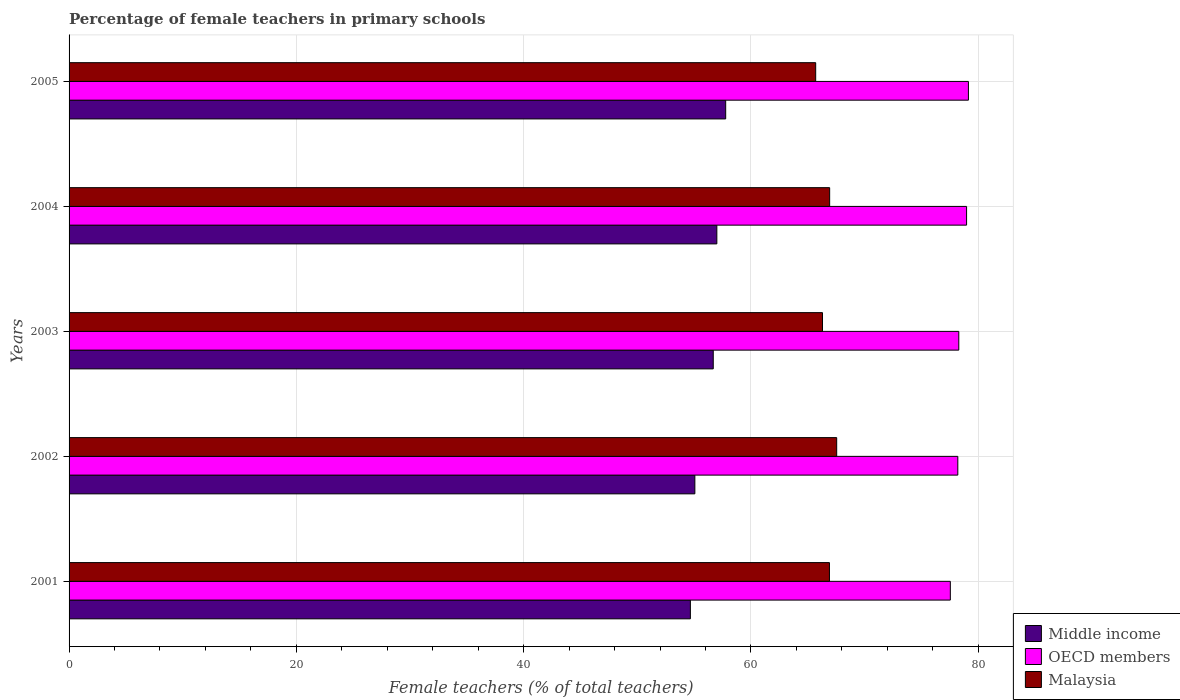How many different coloured bars are there?
Provide a succinct answer. 3. How many groups of bars are there?
Your answer should be compact. 5. Are the number of bars per tick equal to the number of legend labels?
Your answer should be very brief. Yes. Are the number of bars on each tick of the Y-axis equal?
Your answer should be compact. Yes. How many bars are there on the 1st tick from the bottom?
Offer a terse response. 3. What is the label of the 1st group of bars from the top?
Provide a short and direct response. 2005. In how many cases, is the number of bars for a given year not equal to the number of legend labels?
Offer a very short reply. 0. What is the percentage of female teachers in Middle income in 2003?
Provide a succinct answer. 56.68. Across all years, what is the maximum percentage of female teachers in Malaysia?
Ensure brevity in your answer.  67.54. Across all years, what is the minimum percentage of female teachers in OECD members?
Give a very brief answer. 77.54. In which year was the percentage of female teachers in Middle income maximum?
Offer a very short reply. 2005. In which year was the percentage of female teachers in Malaysia minimum?
Ensure brevity in your answer.  2005. What is the total percentage of female teachers in OECD members in the graph?
Offer a terse response. 392.13. What is the difference between the percentage of female teachers in Middle income in 2002 and that in 2003?
Your response must be concise. -1.62. What is the difference between the percentage of female teachers in OECD members in 2001 and the percentage of female teachers in Malaysia in 2003?
Offer a very short reply. 11.25. What is the average percentage of female teachers in Malaysia per year?
Make the answer very short. 66.67. In the year 2002, what is the difference between the percentage of female teachers in Middle income and percentage of female teachers in OECD members?
Your answer should be compact. -23.14. In how many years, is the percentage of female teachers in Middle income greater than 40 %?
Provide a short and direct response. 5. What is the ratio of the percentage of female teachers in OECD members in 2001 to that in 2005?
Make the answer very short. 0.98. Is the percentage of female teachers in Malaysia in 2003 less than that in 2004?
Ensure brevity in your answer.  Yes. Is the difference between the percentage of female teachers in Middle income in 2001 and 2004 greater than the difference between the percentage of female teachers in OECD members in 2001 and 2004?
Your response must be concise. No. What is the difference between the highest and the second highest percentage of female teachers in Malaysia?
Provide a short and direct response. 0.62. What is the difference between the highest and the lowest percentage of female teachers in Middle income?
Provide a short and direct response. 3.11. What does the 3rd bar from the bottom in 2001 represents?
Provide a succinct answer. Malaysia. Are all the bars in the graph horizontal?
Offer a terse response. Yes. How many years are there in the graph?
Offer a terse response. 5. What is the difference between two consecutive major ticks on the X-axis?
Your response must be concise. 20. Are the values on the major ticks of X-axis written in scientific E-notation?
Offer a terse response. No. Does the graph contain grids?
Your response must be concise. Yes. How many legend labels are there?
Keep it short and to the point. 3. What is the title of the graph?
Your answer should be very brief. Percentage of female teachers in primary schools. What is the label or title of the X-axis?
Make the answer very short. Female teachers (% of total teachers). What is the Female teachers (% of total teachers) of Middle income in 2001?
Offer a very short reply. 54.67. What is the Female teachers (% of total teachers) in OECD members in 2001?
Your answer should be very brief. 77.54. What is the Female teachers (% of total teachers) in Malaysia in 2001?
Ensure brevity in your answer.  66.9. What is the Female teachers (% of total teachers) of Middle income in 2002?
Give a very brief answer. 55.06. What is the Female teachers (% of total teachers) in OECD members in 2002?
Your answer should be compact. 78.2. What is the Female teachers (% of total teachers) in Malaysia in 2002?
Provide a succinct answer. 67.54. What is the Female teachers (% of total teachers) in Middle income in 2003?
Keep it short and to the point. 56.68. What is the Female teachers (% of total teachers) in OECD members in 2003?
Your answer should be very brief. 78.29. What is the Female teachers (% of total teachers) of Malaysia in 2003?
Your answer should be very brief. 66.29. What is the Female teachers (% of total teachers) of Middle income in 2004?
Your answer should be compact. 57. What is the Female teachers (% of total teachers) in OECD members in 2004?
Give a very brief answer. 78.97. What is the Female teachers (% of total teachers) of Malaysia in 2004?
Offer a very short reply. 66.92. What is the Female teachers (% of total teachers) of Middle income in 2005?
Offer a terse response. 57.77. What is the Female teachers (% of total teachers) in OECD members in 2005?
Provide a short and direct response. 79.13. What is the Female teachers (% of total teachers) of Malaysia in 2005?
Ensure brevity in your answer.  65.69. Across all years, what is the maximum Female teachers (% of total teachers) in Middle income?
Keep it short and to the point. 57.77. Across all years, what is the maximum Female teachers (% of total teachers) of OECD members?
Your response must be concise. 79.13. Across all years, what is the maximum Female teachers (% of total teachers) of Malaysia?
Make the answer very short. 67.54. Across all years, what is the minimum Female teachers (% of total teachers) in Middle income?
Offer a terse response. 54.67. Across all years, what is the minimum Female teachers (% of total teachers) in OECD members?
Your answer should be very brief. 77.54. Across all years, what is the minimum Female teachers (% of total teachers) of Malaysia?
Provide a succinct answer. 65.69. What is the total Female teachers (% of total teachers) of Middle income in the graph?
Provide a short and direct response. 281.18. What is the total Female teachers (% of total teachers) in OECD members in the graph?
Keep it short and to the point. 392.13. What is the total Female teachers (% of total teachers) of Malaysia in the graph?
Your response must be concise. 333.36. What is the difference between the Female teachers (% of total teachers) of Middle income in 2001 and that in 2002?
Provide a succinct answer. -0.39. What is the difference between the Female teachers (% of total teachers) in OECD members in 2001 and that in 2002?
Your answer should be very brief. -0.66. What is the difference between the Female teachers (% of total teachers) in Malaysia in 2001 and that in 2002?
Provide a succinct answer. -0.64. What is the difference between the Female teachers (% of total teachers) in Middle income in 2001 and that in 2003?
Offer a terse response. -2.01. What is the difference between the Female teachers (% of total teachers) of OECD members in 2001 and that in 2003?
Make the answer very short. -0.74. What is the difference between the Female teachers (% of total teachers) in Malaysia in 2001 and that in 2003?
Your answer should be very brief. 0.61. What is the difference between the Female teachers (% of total teachers) of Middle income in 2001 and that in 2004?
Ensure brevity in your answer.  -2.33. What is the difference between the Female teachers (% of total teachers) of OECD members in 2001 and that in 2004?
Make the answer very short. -1.43. What is the difference between the Female teachers (% of total teachers) of Malaysia in 2001 and that in 2004?
Provide a short and direct response. -0.02. What is the difference between the Female teachers (% of total teachers) of Middle income in 2001 and that in 2005?
Keep it short and to the point. -3.11. What is the difference between the Female teachers (% of total teachers) in OECD members in 2001 and that in 2005?
Offer a very short reply. -1.59. What is the difference between the Female teachers (% of total teachers) in Malaysia in 2001 and that in 2005?
Your answer should be compact. 1.21. What is the difference between the Female teachers (% of total teachers) of Middle income in 2002 and that in 2003?
Your answer should be compact. -1.62. What is the difference between the Female teachers (% of total teachers) of OECD members in 2002 and that in 2003?
Offer a very short reply. -0.09. What is the difference between the Female teachers (% of total teachers) of Malaysia in 2002 and that in 2003?
Make the answer very short. 1.25. What is the difference between the Female teachers (% of total teachers) in Middle income in 2002 and that in 2004?
Provide a short and direct response. -1.93. What is the difference between the Female teachers (% of total teachers) in OECD members in 2002 and that in 2004?
Your answer should be very brief. -0.77. What is the difference between the Female teachers (% of total teachers) in Malaysia in 2002 and that in 2004?
Your answer should be compact. 0.62. What is the difference between the Female teachers (% of total teachers) of Middle income in 2002 and that in 2005?
Your answer should be compact. -2.71. What is the difference between the Female teachers (% of total teachers) of OECD members in 2002 and that in 2005?
Provide a short and direct response. -0.93. What is the difference between the Female teachers (% of total teachers) of Malaysia in 2002 and that in 2005?
Ensure brevity in your answer.  1.85. What is the difference between the Female teachers (% of total teachers) of Middle income in 2003 and that in 2004?
Make the answer very short. -0.32. What is the difference between the Female teachers (% of total teachers) of OECD members in 2003 and that in 2004?
Ensure brevity in your answer.  -0.68. What is the difference between the Female teachers (% of total teachers) in Malaysia in 2003 and that in 2004?
Give a very brief answer. -0.63. What is the difference between the Female teachers (% of total teachers) of Middle income in 2003 and that in 2005?
Offer a terse response. -1.09. What is the difference between the Female teachers (% of total teachers) in OECD members in 2003 and that in 2005?
Your answer should be very brief. -0.85. What is the difference between the Female teachers (% of total teachers) in Malaysia in 2003 and that in 2005?
Offer a very short reply. 0.6. What is the difference between the Female teachers (% of total teachers) in Middle income in 2004 and that in 2005?
Make the answer very short. -0.78. What is the difference between the Female teachers (% of total teachers) in OECD members in 2004 and that in 2005?
Make the answer very short. -0.16. What is the difference between the Female teachers (% of total teachers) in Malaysia in 2004 and that in 2005?
Your answer should be very brief. 1.23. What is the difference between the Female teachers (% of total teachers) of Middle income in 2001 and the Female teachers (% of total teachers) of OECD members in 2002?
Offer a terse response. -23.53. What is the difference between the Female teachers (% of total teachers) in Middle income in 2001 and the Female teachers (% of total teachers) in Malaysia in 2002?
Ensure brevity in your answer.  -12.87. What is the difference between the Female teachers (% of total teachers) of OECD members in 2001 and the Female teachers (% of total teachers) of Malaysia in 2002?
Provide a succinct answer. 10. What is the difference between the Female teachers (% of total teachers) in Middle income in 2001 and the Female teachers (% of total teachers) in OECD members in 2003?
Make the answer very short. -23.62. What is the difference between the Female teachers (% of total teachers) of Middle income in 2001 and the Female teachers (% of total teachers) of Malaysia in 2003?
Your answer should be compact. -11.63. What is the difference between the Female teachers (% of total teachers) of OECD members in 2001 and the Female teachers (% of total teachers) of Malaysia in 2003?
Your response must be concise. 11.25. What is the difference between the Female teachers (% of total teachers) in Middle income in 2001 and the Female teachers (% of total teachers) in OECD members in 2004?
Your answer should be compact. -24.3. What is the difference between the Female teachers (% of total teachers) of Middle income in 2001 and the Female teachers (% of total teachers) of Malaysia in 2004?
Provide a succinct answer. -12.25. What is the difference between the Female teachers (% of total teachers) in OECD members in 2001 and the Female teachers (% of total teachers) in Malaysia in 2004?
Provide a succinct answer. 10.62. What is the difference between the Female teachers (% of total teachers) in Middle income in 2001 and the Female teachers (% of total teachers) in OECD members in 2005?
Keep it short and to the point. -24.46. What is the difference between the Female teachers (% of total teachers) in Middle income in 2001 and the Female teachers (% of total teachers) in Malaysia in 2005?
Your answer should be compact. -11.03. What is the difference between the Female teachers (% of total teachers) in OECD members in 2001 and the Female teachers (% of total teachers) in Malaysia in 2005?
Offer a terse response. 11.85. What is the difference between the Female teachers (% of total teachers) of Middle income in 2002 and the Female teachers (% of total teachers) of OECD members in 2003?
Provide a succinct answer. -23.22. What is the difference between the Female teachers (% of total teachers) of Middle income in 2002 and the Female teachers (% of total teachers) of Malaysia in 2003?
Keep it short and to the point. -11.23. What is the difference between the Female teachers (% of total teachers) of OECD members in 2002 and the Female teachers (% of total teachers) of Malaysia in 2003?
Keep it short and to the point. 11.91. What is the difference between the Female teachers (% of total teachers) of Middle income in 2002 and the Female teachers (% of total teachers) of OECD members in 2004?
Ensure brevity in your answer.  -23.91. What is the difference between the Female teachers (% of total teachers) of Middle income in 2002 and the Female teachers (% of total teachers) of Malaysia in 2004?
Give a very brief answer. -11.86. What is the difference between the Female teachers (% of total teachers) in OECD members in 2002 and the Female teachers (% of total teachers) in Malaysia in 2004?
Your answer should be compact. 11.28. What is the difference between the Female teachers (% of total teachers) of Middle income in 2002 and the Female teachers (% of total teachers) of OECD members in 2005?
Make the answer very short. -24.07. What is the difference between the Female teachers (% of total teachers) of Middle income in 2002 and the Female teachers (% of total teachers) of Malaysia in 2005?
Your answer should be compact. -10.63. What is the difference between the Female teachers (% of total teachers) in OECD members in 2002 and the Female teachers (% of total teachers) in Malaysia in 2005?
Ensure brevity in your answer.  12.51. What is the difference between the Female teachers (% of total teachers) in Middle income in 2003 and the Female teachers (% of total teachers) in OECD members in 2004?
Provide a short and direct response. -22.29. What is the difference between the Female teachers (% of total teachers) of Middle income in 2003 and the Female teachers (% of total teachers) of Malaysia in 2004?
Your answer should be compact. -10.24. What is the difference between the Female teachers (% of total teachers) in OECD members in 2003 and the Female teachers (% of total teachers) in Malaysia in 2004?
Ensure brevity in your answer.  11.36. What is the difference between the Female teachers (% of total teachers) in Middle income in 2003 and the Female teachers (% of total teachers) in OECD members in 2005?
Make the answer very short. -22.45. What is the difference between the Female teachers (% of total teachers) in Middle income in 2003 and the Female teachers (% of total teachers) in Malaysia in 2005?
Provide a succinct answer. -9.01. What is the difference between the Female teachers (% of total teachers) in OECD members in 2003 and the Female teachers (% of total teachers) in Malaysia in 2005?
Offer a very short reply. 12.59. What is the difference between the Female teachers (% of total teachers) in Middle income in 2004 and the Female teachers (% of total teachers) in OECD members in 2005?
Your response must be concise. -22.14. What is the difference between the Female teachers (% of total teachers) of Middle income in 2004 and the Female teachers (% of total teachers) of Malaysia in 2005?
Your answer should be compact. -8.7. What is the difference between the Female teachers (% of total teachers) of OECD members in 2004 and the Female teachers (% of total teachers) of Malaysia in 2005?
Your answer should be very brief. 13.28. What is the average Female teachers (% of total teachers) in Middle income per year?
Provide a short and direct response. 56.24. What is the average Female teachers (% of total teachers) of OECD members per year?
Offer a very short reply. 78.43. What is the average Female teachers (% of total teachers) in Malaysia per year?
Your answer should be very brief. 66.67. In the year 2001, what is the difference between the Female teachers (% of total teachers) of Middle income and Female teachers (% of total teachers) of OECD members?
Your answer should be compact. -22.87. In the year 2001, what is the difference between the Female teachers (% of total teachers) in Middle income and Female teachers (% of total teachers) in Malaysia?
Give a very brief answer. -12.24. In the year 2001, what is the difference between the Female teachers (% of total teachers) in OECD members and Female teachers (% of total teachers) in Malaysia?
Give a very brief answer. 10.64. In the year 2002, what is the difference between the Female teachers (% of total teachers) in Middle income and Female teachers (% of total teachers) in OECD members?
Make the answer very short. -23.14. In the year 2002, what is the difference between the Female teachers (% of total teachers) in Middle income and Female teachers (% of total teachers) in Malaysia?
Offer a terse response. -12.48. In the year 2002, what is the difference between the Female teachers (% of total teachers) in OECD members and Female teachers (% of total teachers) in Malaysia?
Provide a short and direct response. 10.66. In the year 2003, what is the difference between the Female teachers (% of total teachers) of Middle income and Female teachers (% of total teachers) of OECD members?
Provide a short and direct response. -21.6. In the year 2003, what is the difference between the Female teachers (% of total teachers) in Middle income and Female teachers (% of total teachers) in Malaysia?
Keep it short and to the point. -9.61. In the year 2003, what is the difference between the Female teachers (% of total teachers) in OECD members and Female teachers (% of total teachers) in Malaysia?
Offer a terse response. 11.99. In the year 2004, what is the difference between the Female teachers (% of total teachers) of Middle income and Female teachers (% of total teachers) of OECD members?
Make the answer very short. -21.97. In the year 2004, what is the difference between the Female teachers (% of total teachers) in Middle income and Female teachers (% of total teachers) in Malaysia?
Ensure brevity in your answer.  -9.93. In the year 2004, what is the difference between the Female teachers (% of total teachers) in OECD members and Female teachers (% of total teachers) in Malaysia?
Provide a succinct answer. 12.05. In the year 2005, what is the difference between the Female teachers (% of total teachers) in Middle income and Female teachers (% of total teachers) in OECD members?
Offer a very short reply. -21.36. In the year 2005, what is the difference between the Female teachers (% of total teachers) of Middle income and Female teachers (% of total teachers) of Malaysia?
Provide a short and direct response. -7.92. In the year 2005, what is the difference between the Female teachers (% of total teachers) in OECD members and Female teachers (% of total teachers) in Malaysia?
Keep it short and to the point. 13.44. What is the ratio of the Female teachers (% of total teachers) in Middle income in 2001 to that in 2002?
Make the answer very short. 0.99. What is the ratio of the Female teachers (% of total teachers) of OECD members in 2001 to that in 2002?
Ensure brevity in your answer.  0.99. What is the ratio of the Female teachers (% of total teachers) of Malaysia in 2001 to that in 2002?
Your answer should be very brief. 0.99. What is the ratio of the Female teachers (% of total teachers) of Middle income in 2001 to that in 2003?
Your response must be concise. 0.96. What is the ratio of the Female teachers (% of total teachers) in Malaysia in 2001 to that in 2003?
Your answer should be very brief. 1.01. What is the ratio of the Female teachers (% of total teachers) of Middle income in 2001 to that in 2004?
Your answer should be compact. 0.96. What is the ratio of the Female teachers (% of total teachers) in OECD members in 2001 to that in 2004?
Your response must be concise. 0.98. What is the ratio of the Female teachers (% of total teachers) in Malaysia in 2001 to that in 2004?
Give a very brief answer. 1. What is the ratio of the Female teachers (% of total teachers) in Middle income in 2001 to that in 2005?
Give a very brief answer. 0.95. What is the ratio of the Female teachers (% of total teachers) of OECD members in 2001 to that in 2005?
Your answer should be very brief. 0.98. What is the ratio of the Female teachers (% of total teachers) in Malaysia in 2001 to that in 2005?
Your answer should be compact. 1.02. What is the ratio of the Female teachers (% of total teachers) in Middle income in 2002 to that in 2003?
Give a very brief answer. 0.97. What is the ratio of the Female teachers (% of total teachers) in OECD members in 2002 to that in 2003?
Your answer should be very brief. 1. What is the ratio of the Female teachers (% of total teachers) in Malaysia in 2002 to that in 2003?
Keep it short and to the point. 1.02. What is the ratio of the Female teachers (% of total teachers) in Middle income in 2002 to that in 2004?
Your response must be concise. 0.97. What is the ratio of the Female teachers (% of total teachers) in OECD members in 2002 to that in 2004?
Keep it short and to the point. 0.99. What is the ratio of the Female teachers (% of total teachers) of Malaysia in 2002 to that in 2004?
Keep it short and to the point. 1.01. What is the ratio of the Female teachers (% of total teachers) in Middle income in 2002 to that in 2005?
Give a very brief answer. 0.95. What is the ratio of the Female teachers (% of total teachers) in OECD members in 2002 to that in 2005?
Make the answer very short. 0.99. What is the ratio of the Female teachers (% of total teachers) of Malaysia in 2002 to that in 2005?
Ensure brevity in your answer.  1.03. What is the ratio of the Female teachers (% of total teachers) in Middle income in 2003 to that in 2004?
Provide a short and direct response. 0.99. What is the ratio of the Female teachers (% of total teachers) of Malaysia in 2003 to that in 2004?
Offer a very short reply. 0.99. What is the ratio of the Female teachers (% of total teachers) in Middle income in 2003 to that in 2005?
Your response must be concise. 0.98. What is the ratio of the Female teachers (% of total teachers) in OECD members in 2003 to that in 2005?
Your answer should be very brief. 0.99. What is the ratio of the Female teachers (% of total teachers) in Malaysia in 2003 to that in 2005?
Offer a very short reply. 1.01. What is the ratio of the Female teachers (% of total teachers) of Middle income in 2004 to that in 2005?
Give a very brief answer. 0.99. What is the ratio of the Female teachers (% of total teachers) of OECD members in 2004 to that in 2005?
Give a very brief answer. 1. What is the ratio of the Female teachers (% of total teachers) in Malaysia in 2004 to that in 2005?
Your response must be concise. 1.02. What is the difference between the highest and the second highest Female teachers (% of total teachers) in Middle income?
Provide a short and direct response. 0.78. What is the difference between the highest and the second highest Female teachers (% of total teachers) in OECD members?
Your answer should be very brief. 0.16. What is the difference between the highest and the second highest Female teachers (% of total teachers) in Malaysia?
Offer a terse response. 0.62. What is the difference between the highest and the lowest Female teachers (% of total teachers) in Middle income?
Offer a terse response. 3.11. What is the difference between the highest and the lowest Female teachers (% of total teachers) of OECD members?
Give a very brief answer. 1.59. What is the difference between the highest and the lowest Female teachers (% of total teachers) of Malaysia?
Your answer should be compact. 1.85. 